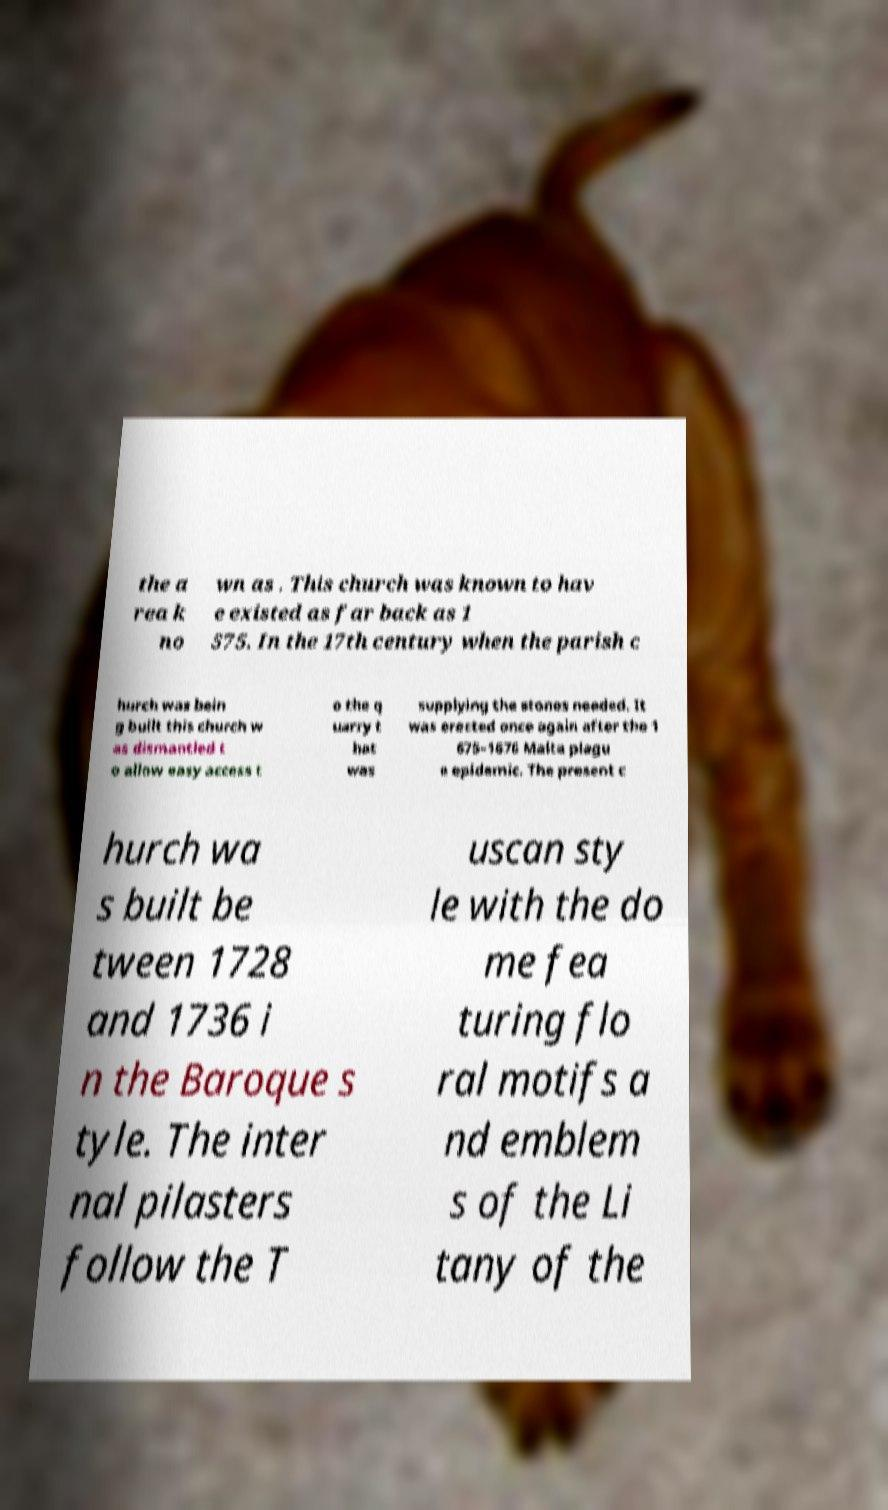Can you read and provide the text displayed in the image?This photo seems to have some interesting text. Can you extract and type it out for me? the a rea k no wn as . This church was known to hav e existed as far back as 1 575. In the 17th century when the parish c hurch was bein g built this church w as dismantled t o allow easy access t o the q uarry t hat was supplying the stones needed. It was erected once again after the 1 675–1676 Malta plagu e epidemic. The present c hurch wa s built be tween 1728 and 1736 i n the Baroque s tyle. The inter nal pilasters follow the T uscan sty le with the do me fea turing flo ral motifs a nd emblem s of the Li tany of the 